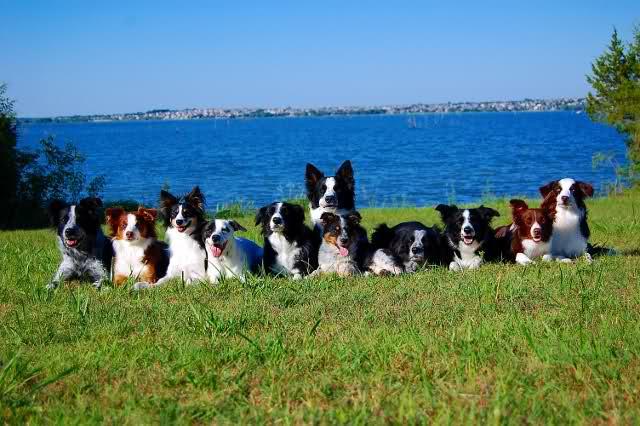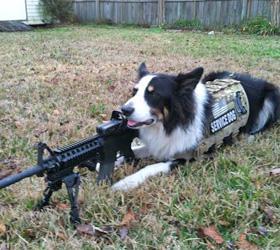The first image is the image on the left, the second image is the image on the right. Analyze the images presented: Is the assertion "A horizontal row of reclining dogs poses in front of some type of rail structure." valid? Answer yes or no. No. The first image is the image on the left, the second image is the image on the right. For the images shown, is this caption "There are four dogs in the left image." true? Answer yes or no. No. 